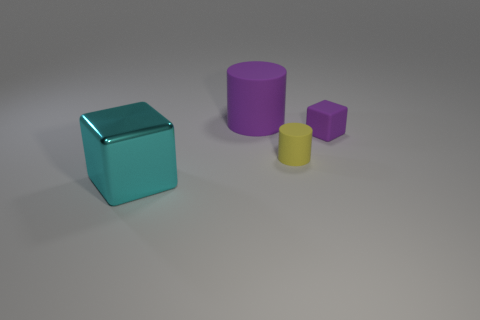Add 3 small brown cylinders. How many objects exist? 7 Subtract all large shiny cubes. Subtract all small purple metal balls. How many objects are left? 3 Add 3 large matte cylinders. How many large matte cylinders are left? 4 Add 1 small brown cylinders. How many small brown cylinders exist? 1 Subtract all purple cubes. How many cubes are left? 1 Subtract 0 yellow balls. How many objects are left? 4 Subtract 1 cylinders. How many cylinders are left? 1 Subtract all blue cylinders. Subtract all yellow balls. How many cylinders are left? 2 Subtract all yellow cubes. How many cyan cylinders are left? 0 